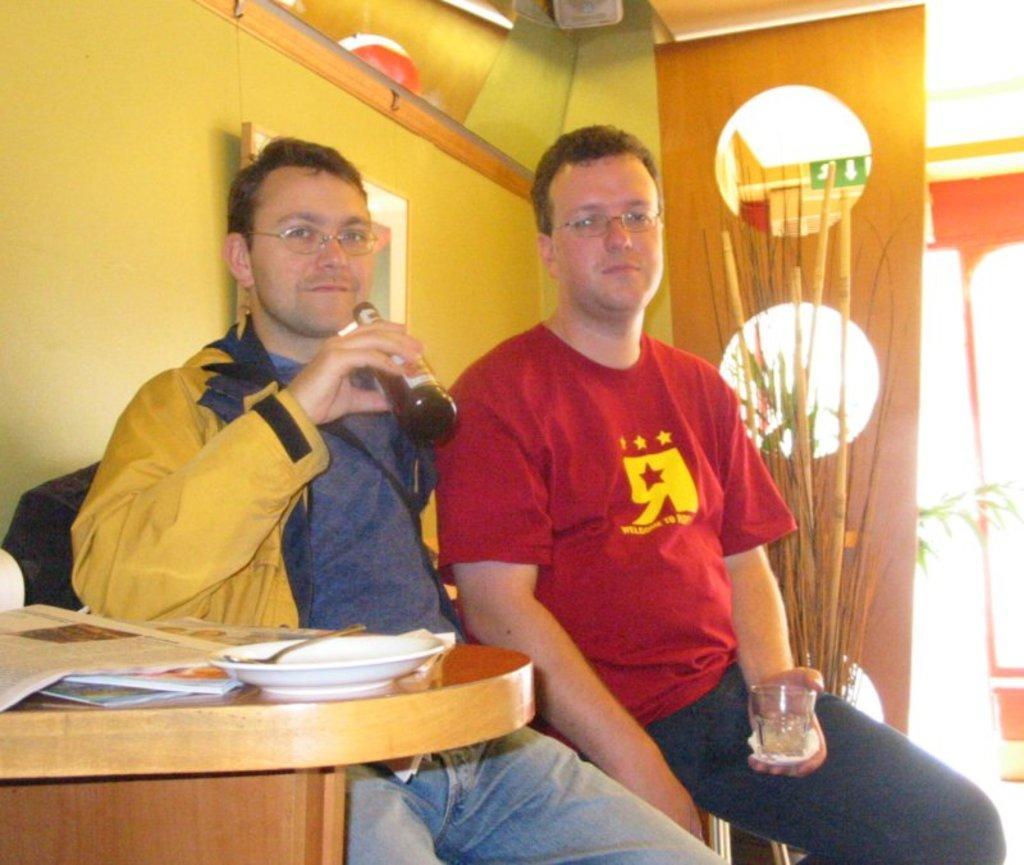Can you describe this image briefly? In this picture we can see two persons, among them one person is holding bottle, another person is holding glass, side we can see table on which there are some papers, objects, behind we can see pot and wall. 